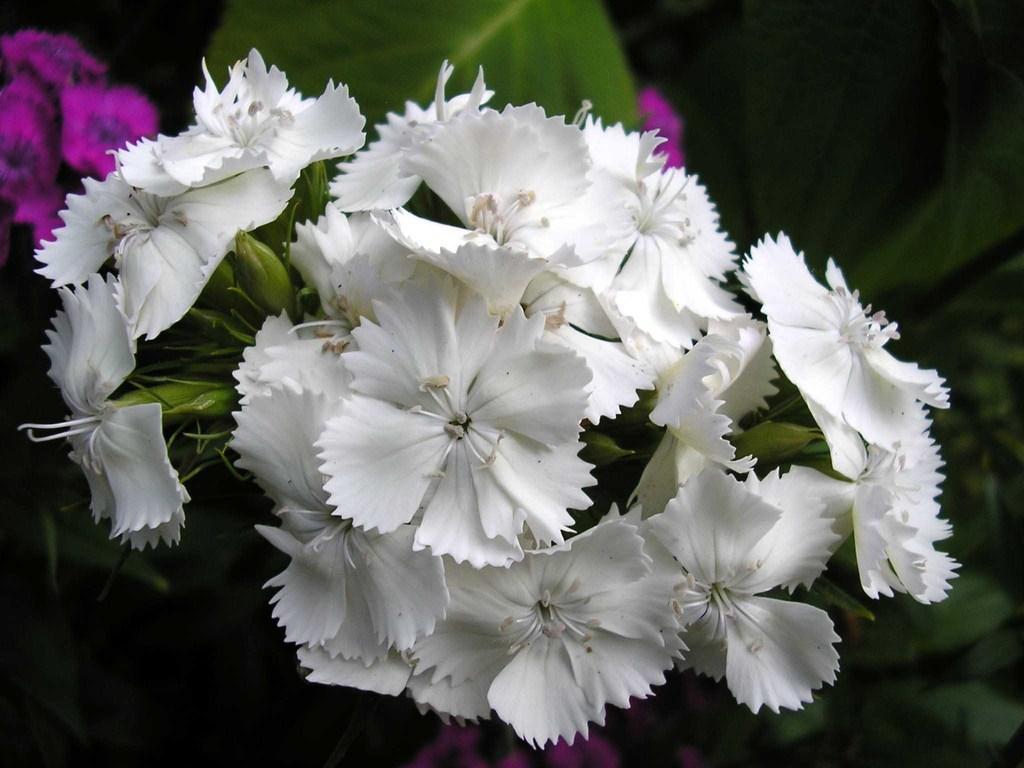In one or two sentences, can you explain what this image depicts? In this image in the front there are flowers. 